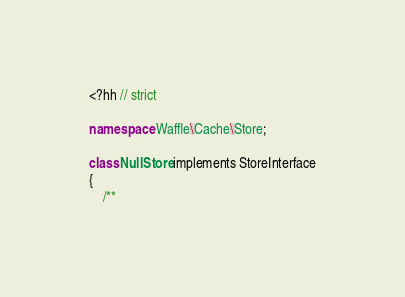Convert code to text. <code><loc_0><loc_0><loc_500><loc_500><_C++_><?hh // strict

namespace Waffle\Cache\Store;

class NullStore implements StoreInterface
{
    /**</code> 